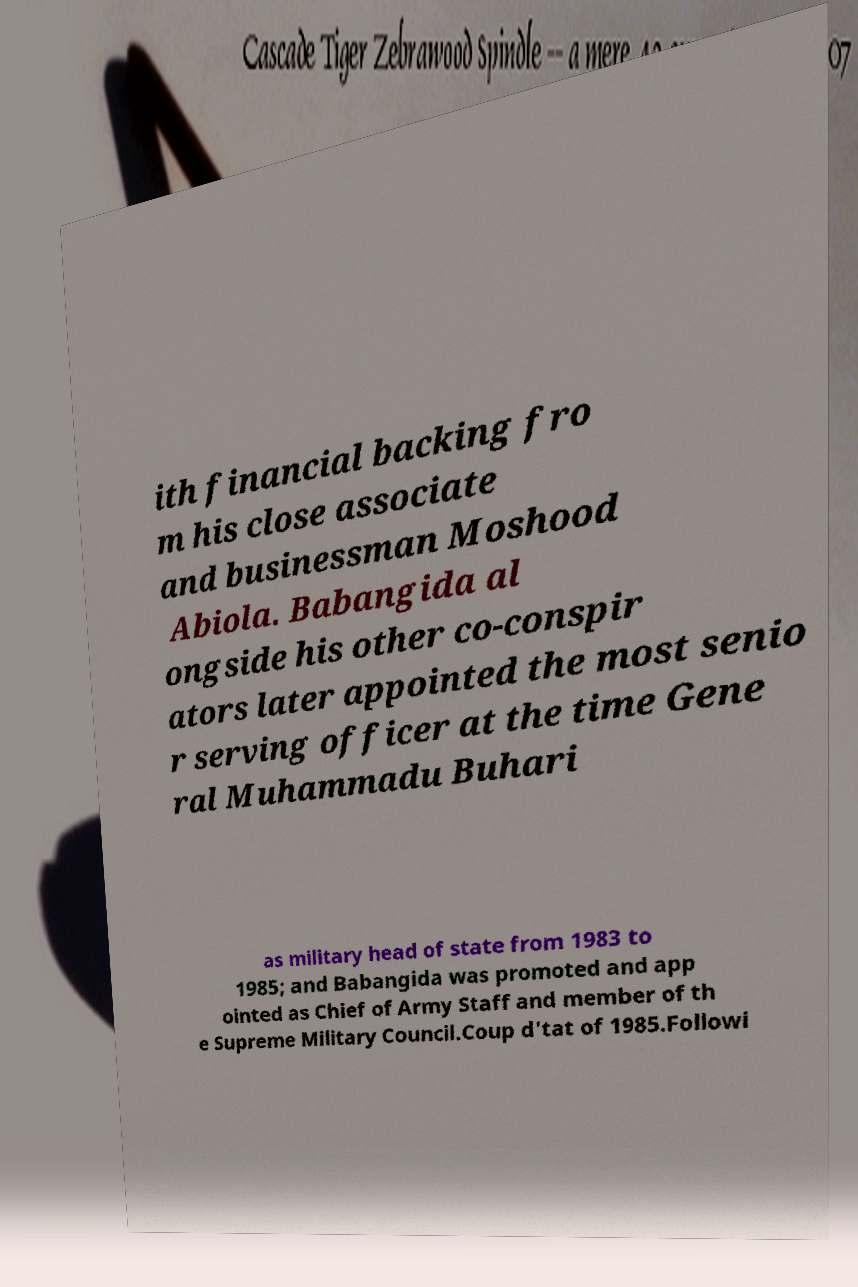Please identify and transcribe the text found in this image. ith financial backing fro m his close associate and businessman Moshood Abiola. Babangida al ongside his other co-conspir ators later appointed the most senio r serving officer at the time Gene ral Muhammadu Buhari as military head of state from 1983 to 1985; and Babangida was promoted and app ointed as Chief of Army Staff and member of th e Supreme Military Council.Coup d'tat of 1985.Followi 